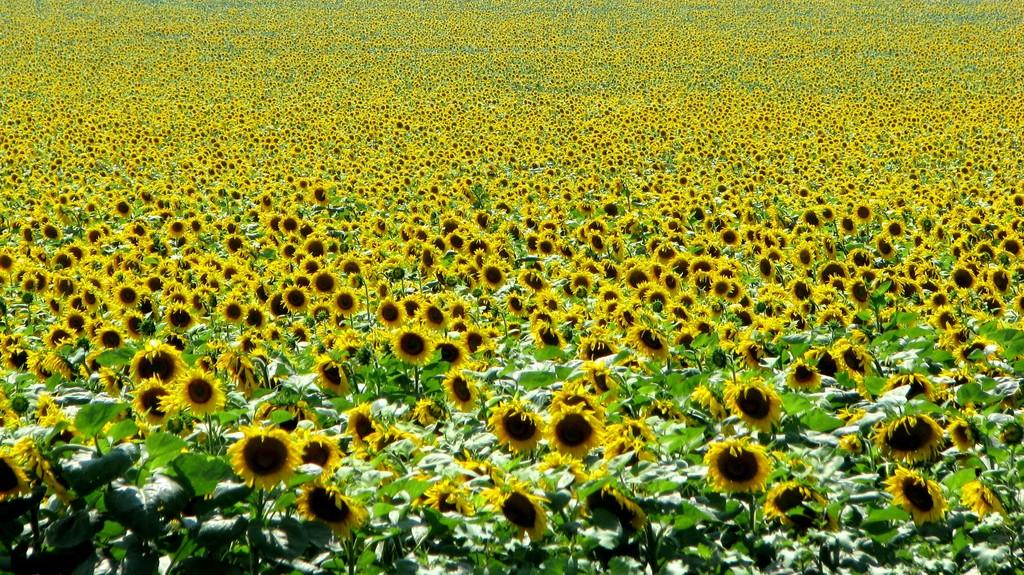What is the main subject of the image? The main subject of the image is a sunflower plant field. How does the jellyfish light up the sunflower plant field in the image? There are no jellyfish present in the image, and therefore no such lighting effect can be observed. 